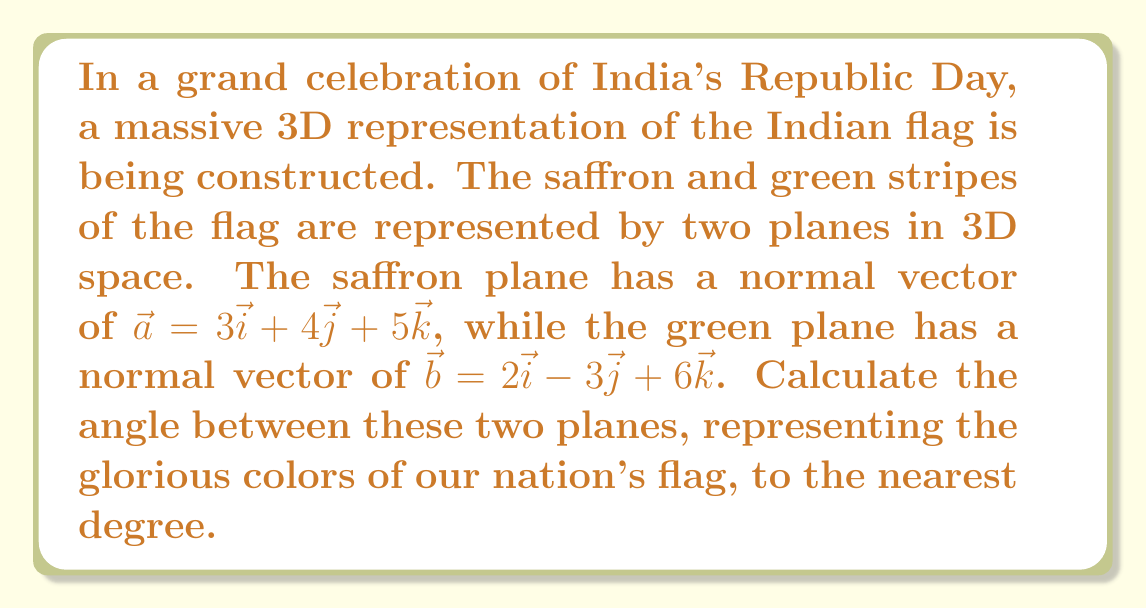Give your solution to this math problem. To find the angle between two planes, we need to calculate the angle between their normal vectors. Let's approach this step-by-step:

1) We have two normal vectors:
   $\vec{a} = 3\vec{i} + 4\vec{j} + 5\vec{k}$
   $\vec{b} = 2\vec{i} - 3\vec{j} + 6\vec{k}$

2) The angle $\theta$ between two vectors $\vec{a}$ and $\vec{b}$ is given by the formula:

   $$\cos \theta = \frac{\vec{a} \cdot \vec{b}}{|\vec{a}||\vec{b}|}$$

3) Let's calculate the dot product $\vec{a} \cdot \vec{b}$:
   $\vec{a} \cdot \vec{b} = (3)(2) + (4)(-3) + (5)(6) = 6 - 12 + 30 = 24$

4) Now, let's calculate the magnitudes:
   $|\vec{a}| = \sqrt{3^2 + 4^2 + 5^2} = \sqrt{9 + 16 + 25} = \sqrt{50}$
   $|\vec{b}| = \sqrt{2^2 + (-3)^2 + 6^2} = \sqrt{4 + 9 + 36} = \sqrt{49} = 7$

5) Substituting into our formula:

   $$\cos \theta = \frac{24}{\sqrt{50} \cdot 7}$$

6) Simplifying:
   $$\cos \theta = \frac{24}{7\sqrt{50}} = \frac{24}{7\sqrt{2} \cdot 5}$$

7) To find $\theta$, we take the inverse cosine (arccos) of both sides:

   $$\theta = \arccos(\frac{24}{7\sqrt{50}})$$

8) Using a calculator and rounding to the nearest degree:
   $\theta \approx 53°$

Therefore, the angle between the saffron and green planes of our majestic Indian flag representation is approximately 53°.
Answer: 53° 